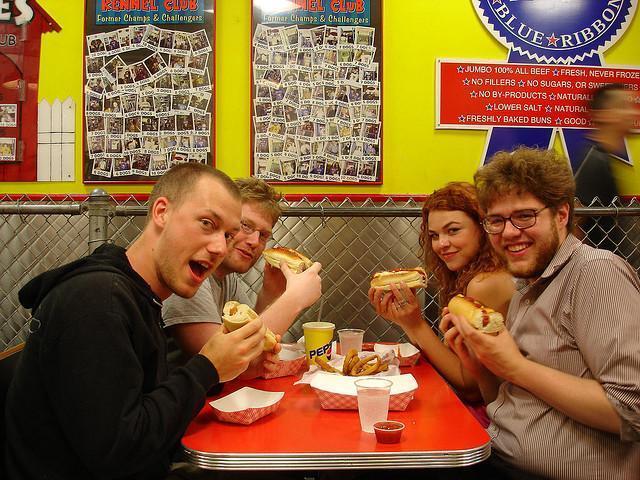How many people are there?
Give a very brief answer. 4. How many people can you see?
Give a very brief answer. 5. How many laptops are in the picture?
Give a very brief answer. 0. 